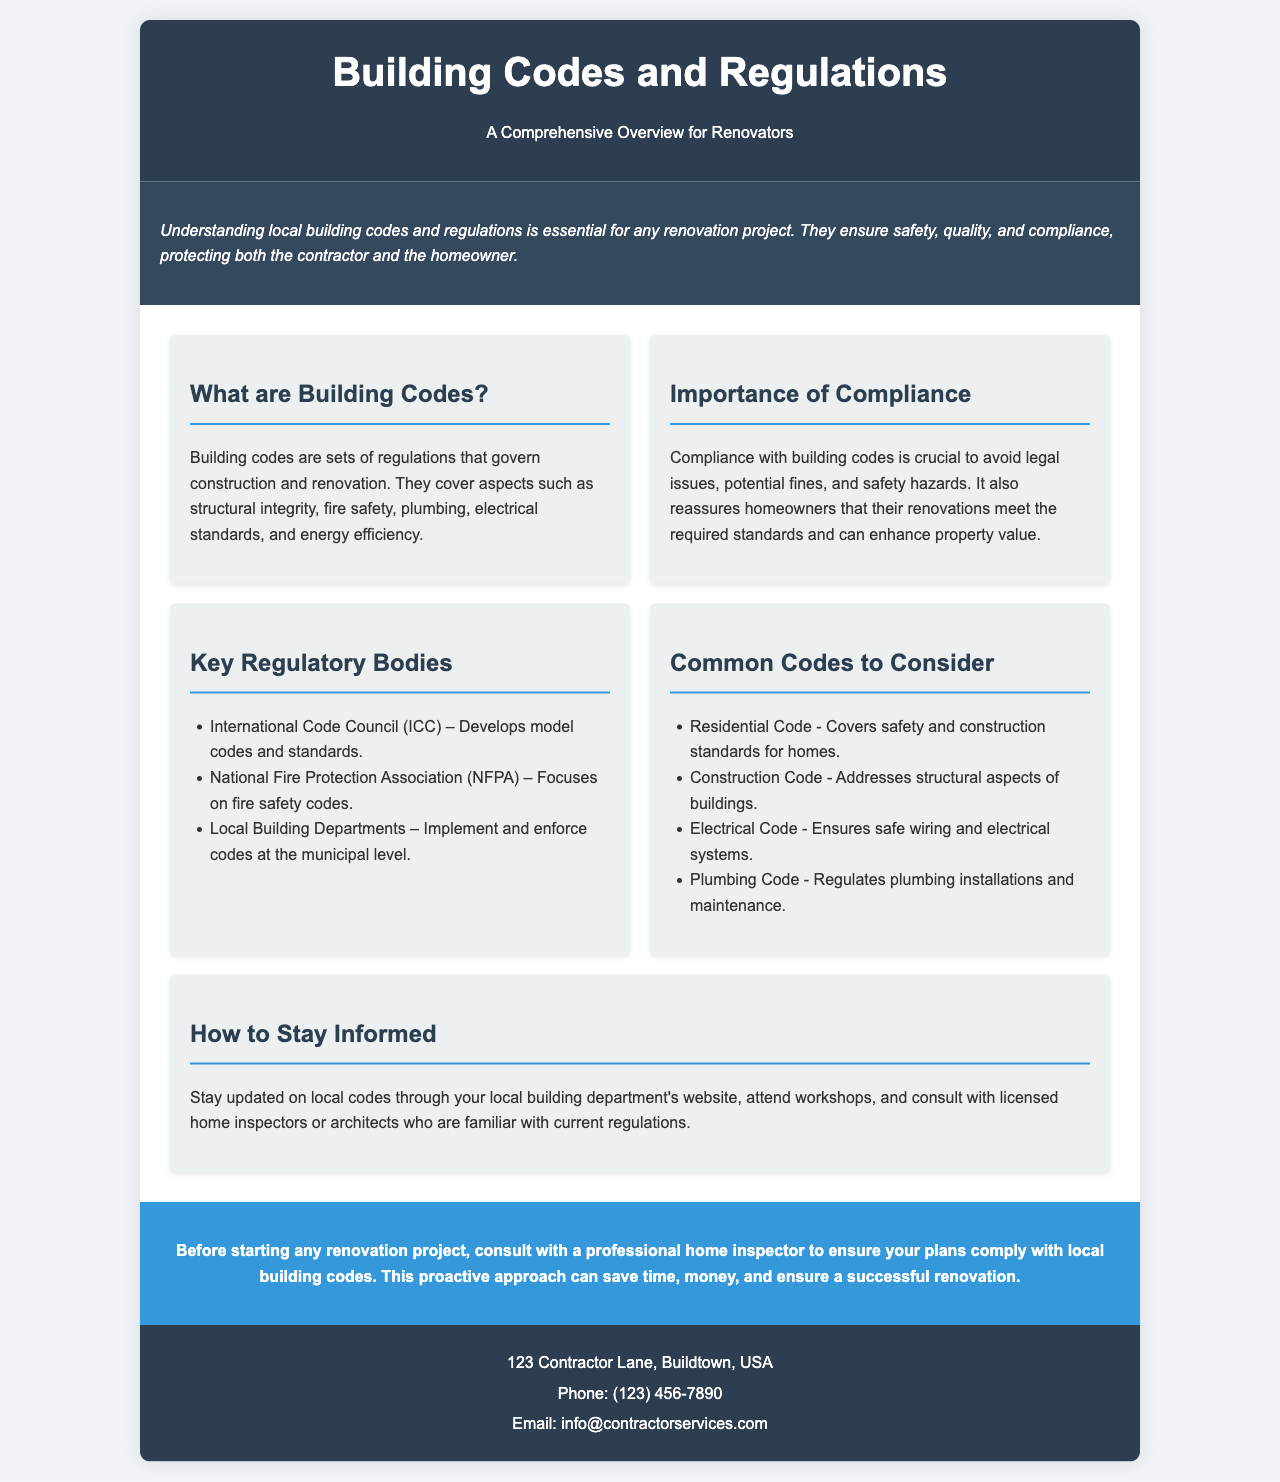What are building codes? Building codes are sets of regulations that govern construction and renovation.
Answer: Sets of regulations Why is compliance important? Compliance is crucial to avoid legal issues, potential fines, and safety hazards.
Answer: Avoid legal issues Who develops model codes? The International Code Council (ICC) develops model codes and standards.
Answer: International Code Council What does the Electrical Code ensure? The Electrical Code ensures safe wiring and electrical systems.
Answer: Safe wiring How can you stay informed about local codes? Stay updated through your local building department's website, attend workshops, and consult with professionals.
Answer: Local building department's website What is covered under the Residential Code? The Residential Code covers safety and construction standards for homes.
Answer: Safety and construction standards Where is the contact information located? The contact information is located in the contact section at the bottom of the brochure.
Answer: Bottom of the brochure What is the address provided in the contact section? The address provided is 123 Contractor Lane, Buildtown, USA.
Answer: 123 Contractor Lane, Buildtown, USA 